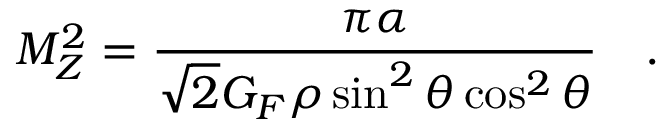<formula> <loc_0><loc_0><loc_500><loc_500>M _ { Z } ^ { 2 } = \frac { \pi \alpha } { \sqrt { 2 } G _ { F } \rho \sin ^ { 2 } \theta \cos ^ { 2 } \theta } .</formula> 